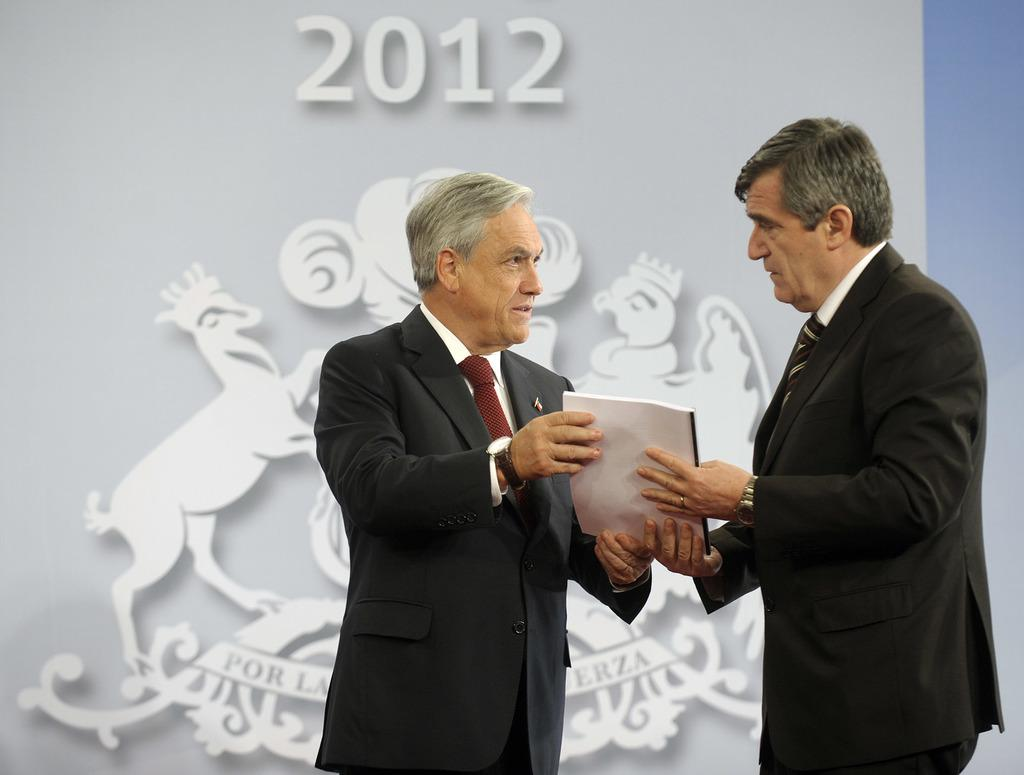How many people are in the image? There are two men in the image. What are the men doing in the image? The men are standing and holding a book. What are the men wearing in the image? The men are wearing suits. What can be seen in the background of the image? There is a logo and text in the background of the image. Can you tell me what the fireman is doing in the image? There is no fireman present in the image; it features two men holding a book. What type of tank can be seen in the image? There is no tank present in the image; it features two men holding a book and a background with a logo and text. 